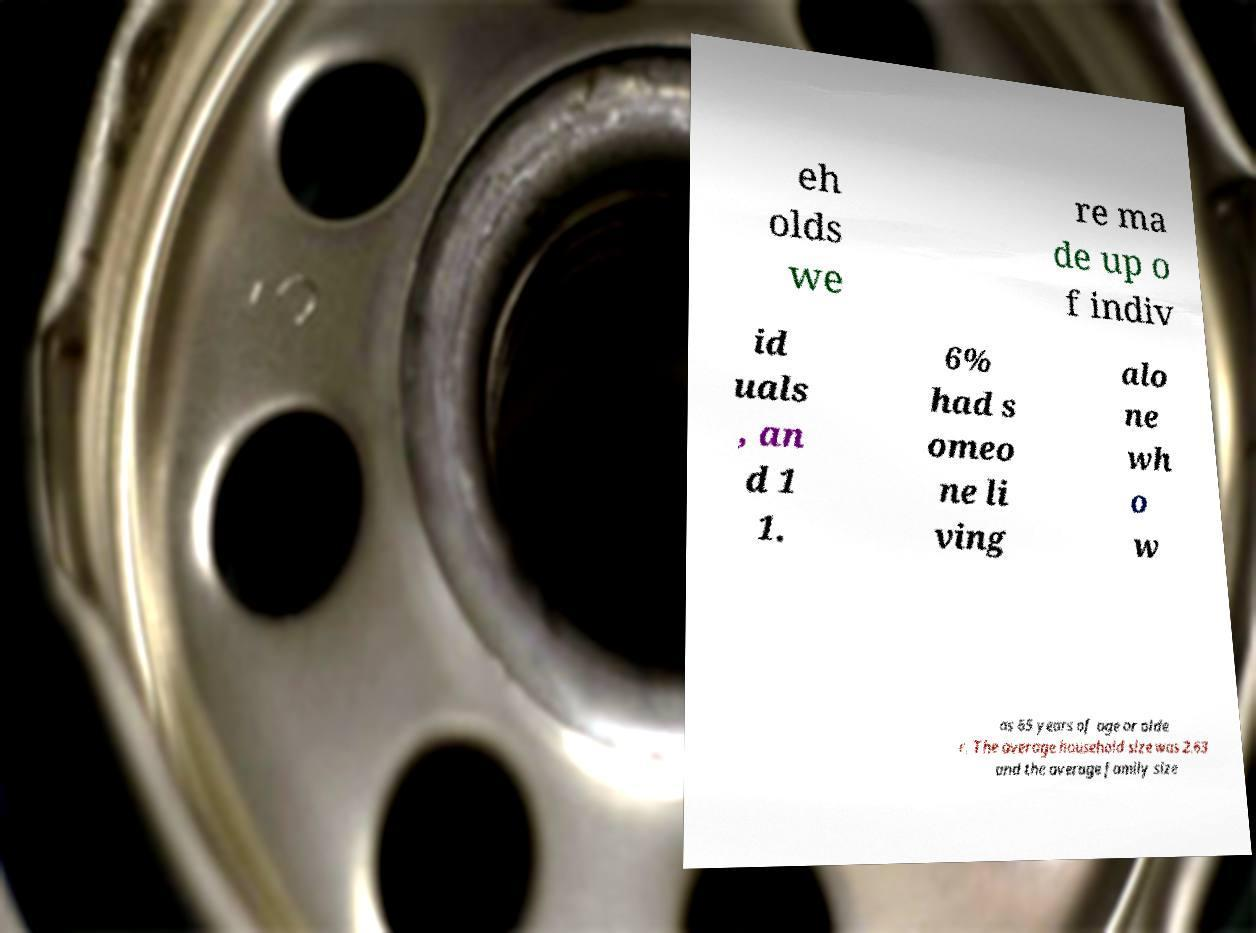Could you extract and type out the text from this image? eh olds we re ma de up o f indiv id uals , an d 1 1. 6% had s omeo ne li ving alo ne wh o w as 65 years of age or olde r. The average household size was 2.63 and the average family size 